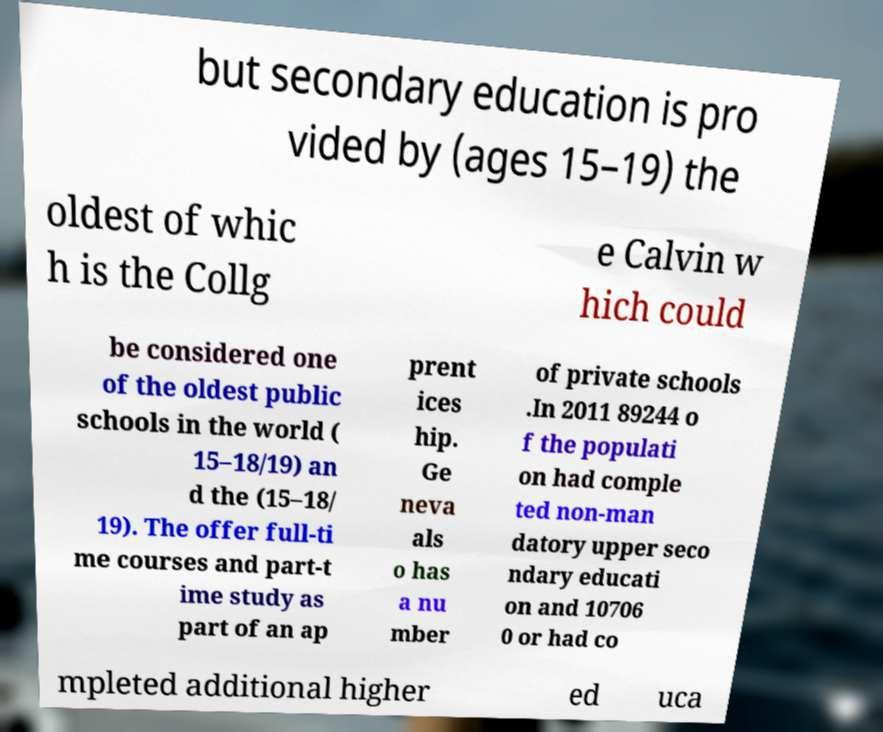Can you accurately transcribe the text from the provided image for me? but secondary education is pro vided by (ages 15–19) the oldest of whic h is the Collg e Calvin w hich could be considered one of the oldest public schools in the world ( 15–18/19) an d the (15–18/ 19). The offer full-ti me courses and part-t ime study as part of an ap prent ices hip. Ge neva als o has a nu mber of private schools .In 2011 89244 o f the populati on had comple ted non-man datory upper seco ndary educati on and 10706 0 or had co mpleted additional higher ed uca 